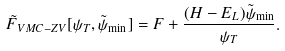<formula> <loc_0><loc_0><loc_500><loc_500>\tilde { F } _ { V M C - Z V } [ \psi _ { T } , \tilde { \psi } _ { \min } ] = F + \frac { ( H - { E _ { L } } ) { \tilde { \psi } _ { \min } } } { \psi _ { T } } .</formula> 